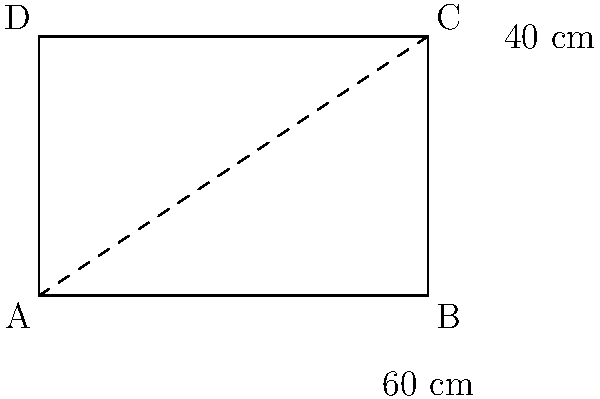You have a rectangular wooden cutting board in your kitchen. The length of the board is 60 cm and its width is 40 cm. To ensure it fits in your kitchen drawer, you need to measure its diagonal length. What is the length of the diagonal of this cutting board? To find the diagonal length of a rectangular cutting board, we can use the Pythagorean theorem. Let's solve this step-by-step:

1. Let the diagonal length be $d$ cm.
2. The length of the cutting board is 60 cm and the width is 40 cm.
3. According to the Pythagorean theorem: $d^2 = 60^2 + 40^2$

4. Let's calculate:
   $d^2 = 60^2 + 40^2$
   $d^2 = 3600 + 1600$
   $d^2 = 5200$

5. To find $d$, we need to take the square root of both sides:
   $d = \sqrt{5200}$

6. Simplify:
   $d = 20\sqrt{13}$ cm

7. If we need an approximate decimal value:
   $d \approx 72.11$ cm

Therefore, the diagonal length of the cutting board is $20\sqrt{13}$ cm or approximately 72.11 cm.
Answer: $20\sqrt{13}$ cm 